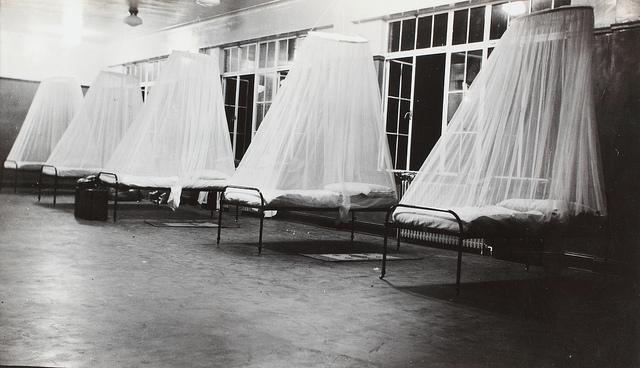How many beds are in the room?
Quick response, please. 5. Does this look like a hospital?
Short answer required. Yes. How many beds are there?
Give a very brief answer. 5. 